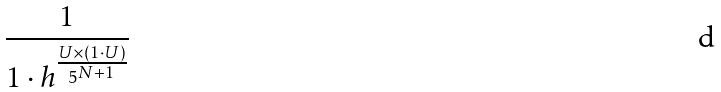Convert formula to latex. <formula><loc_0><loc_0><loc_500><loc_500>\frac { 1 } { 1 \cdot h ^ { \frac { U \times ( 1 \cdot U ) } { 5 ^ { N + 1 } } } }</formula> 